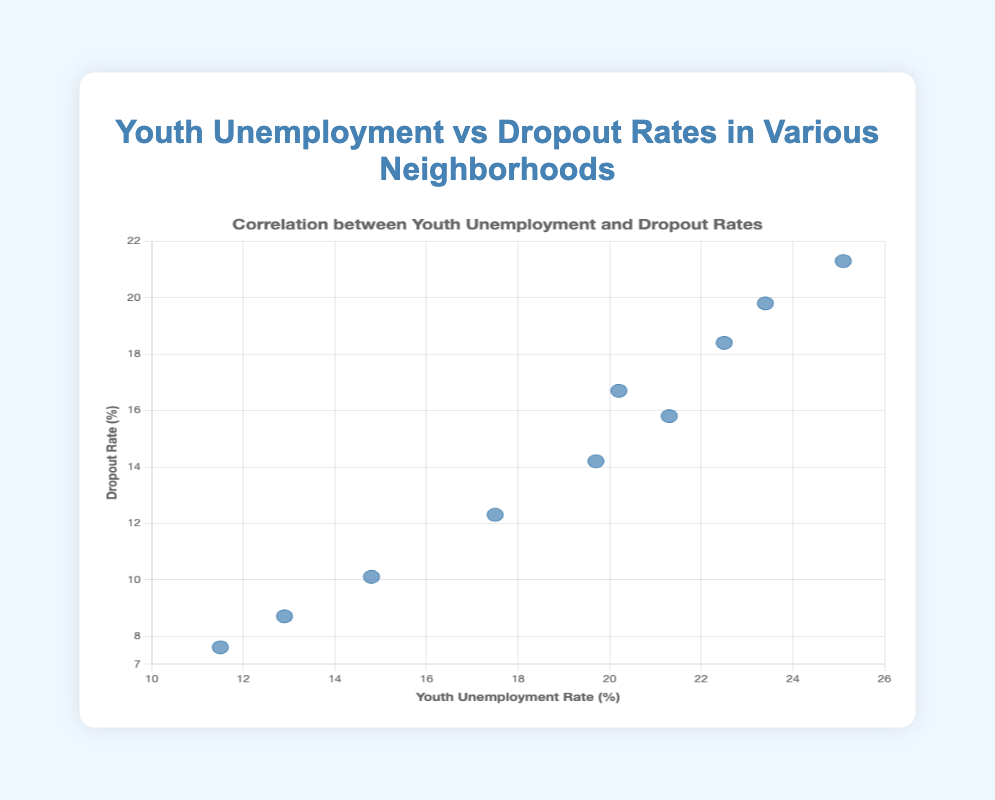What does the title of the scatter plot indicate? The title mentions "Youth Unemployment vs Dropout Rates in Various Neighborhoods," indicating that the scatter plot will show the relationship between the unemployment rates of youth and dropout rates across different neighborhoods.
Answer: The plot displays the relationship between youth unemployment and dropout rates What does the x-axis represent, and what is its range? The x-axis represents the "Youth Unemployment Rate (%)" and ranges from 10% to 26%. This axis shows the percentage of unemployed youth in each neighborhood.
Answer: Youth Unemployment Rate (%) ranging from 10% to 26% How many neighborhoods are represented in the scatter plot? By counting the number of points (or data markers) on the scatter plot, we can determine the number of neighborhoods. There are 10 data points, so there are 10 neighborhoods represented.
Answer: 10 neighborhoods Which neighborhood has the highest dropout rate, and what is the dropout rate? By identifying the point that is highest on the y-axis, we find that Watts has the highest dropout rate. The corresponding y-value is 21.3%.
Answer: Watts, 21.3% Are there any neighborhoods with a youth unemployment rate below 12%? Checking the data points along the x-axis (Youth Unemployment Rate), we see that Staten Island is the only neighborhood with a youth unemployment rate below 12%, at 11.5%.
Answer: Staten Island Is there a neighborhood with both a lower unemployment rate and a lower dropout rate than Harlem? Looking for a point that is both left of (lower unemployment rate) and below (lower dropout rate) the point representing Harlem (21.3, 15.8), Queens (14.8, 10.1), Manhattan (12.9, 8.7), and Staten Island (11.5, 7.6) meet this criterion.
Answer: Yes, Queens, Manhattan, and Staten Island Calculate the average youth unemployment rate of Manhattan and Staten Island The youth unemployment rates for Manhattan and Staten Island are 12.9% and 11.5%, respectively. Adding these two values and dividing by 2 gives the average: (12.9 + 11.5) / 2 = 12.2%.
Answer: 12.2% Which neighborhood has the closest relationship between Youth Unemployment Rate and Dropout Rate? The neighborhood with the point closest to a line where youth unemployment rate equals dropout rate is Watts, as its coordinates are close to each other (25.1, 21.3).
Answer: Watts Is there a noticeable trend or correlation between youth unemployment and dropout rates? Observing the scatter points, we notice that as the youth unemployment rate increases, the dropout rate also tends to increase. This suggests a positive correlation between youth unemployment rates and dropout rates in the neighborhoods.
Answer: Yes, a positive correlation 